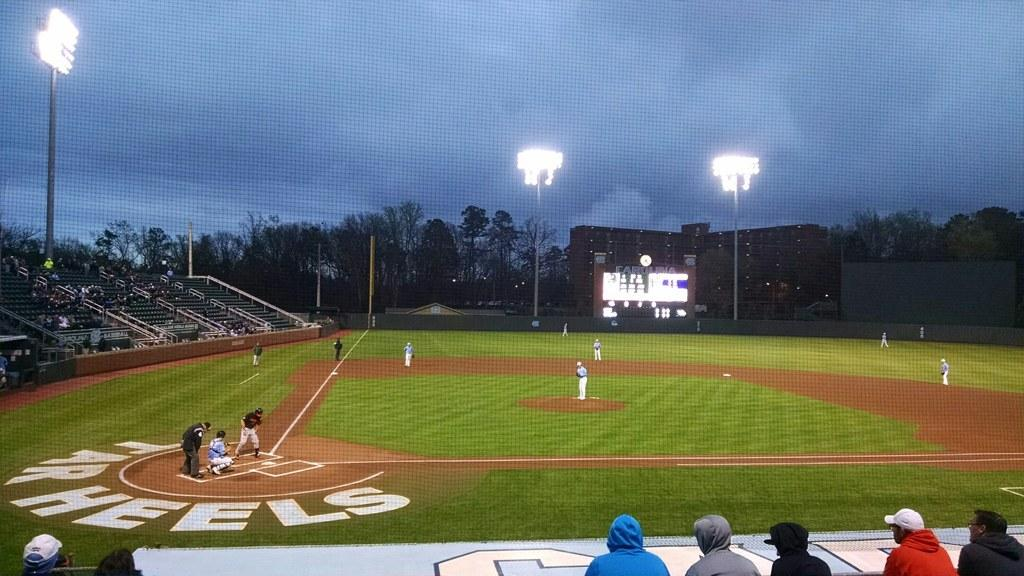<image>
Relay a brief, clear account of the picture shown. Tar Heels surrounds home plate in this baseball stadium. 